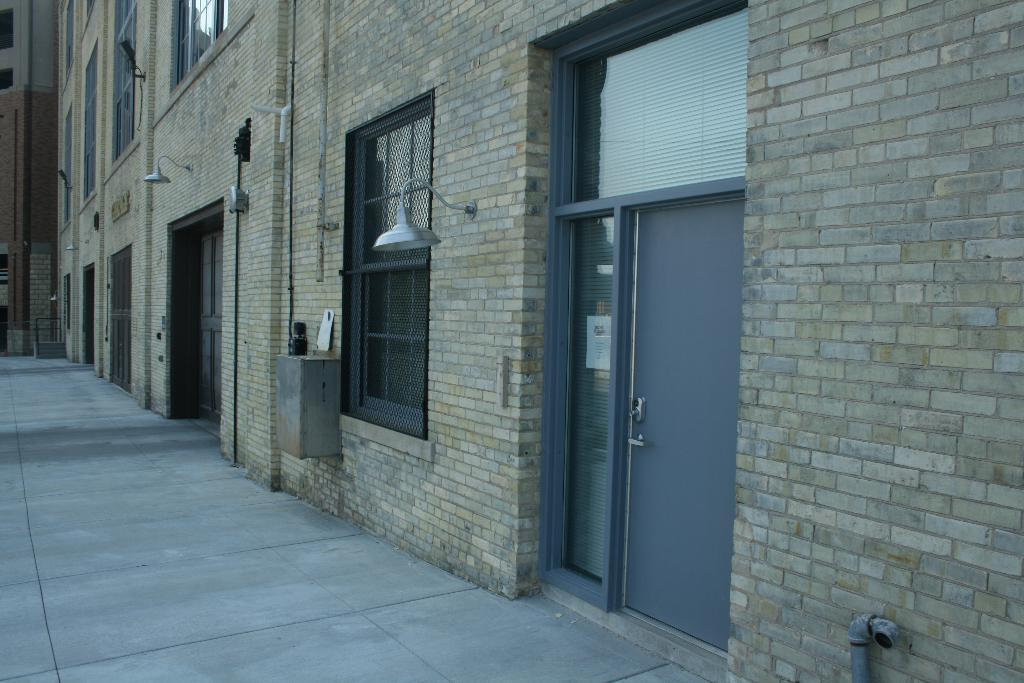What is located in the middle of the image? There are buildings in the middle of the image. What features do the buildings have? The buildings have doors and windows. Are there any additional details visible on the buildings? Yes, there are lights on the buildings. Is there a twig visible in the image? There is no mention of a twig in the image, so it cannot be seen. 